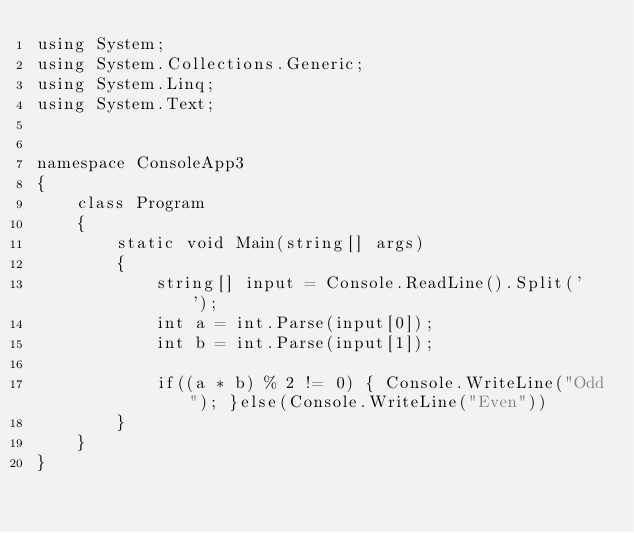<code> <loc_0><loc_0><loc_500><loc_500><_C#_>using System;
using System.Collections.Generic;
using System.Linq;
using System.Text;


namespace ConsoleApp3
{
    class Program
    {
        static void Main(string[] args)
        {
            string[] input = Console.ReadLine().Split(' ');
            int a = int.Parse(input[0]);
            int b = int.Parse(input[1]);

            if((a * b) % 2 != 0) { Console.WriteLine("Odd"); }else(Console.WriteLine("Even"))
        }
    }
}
</code> 